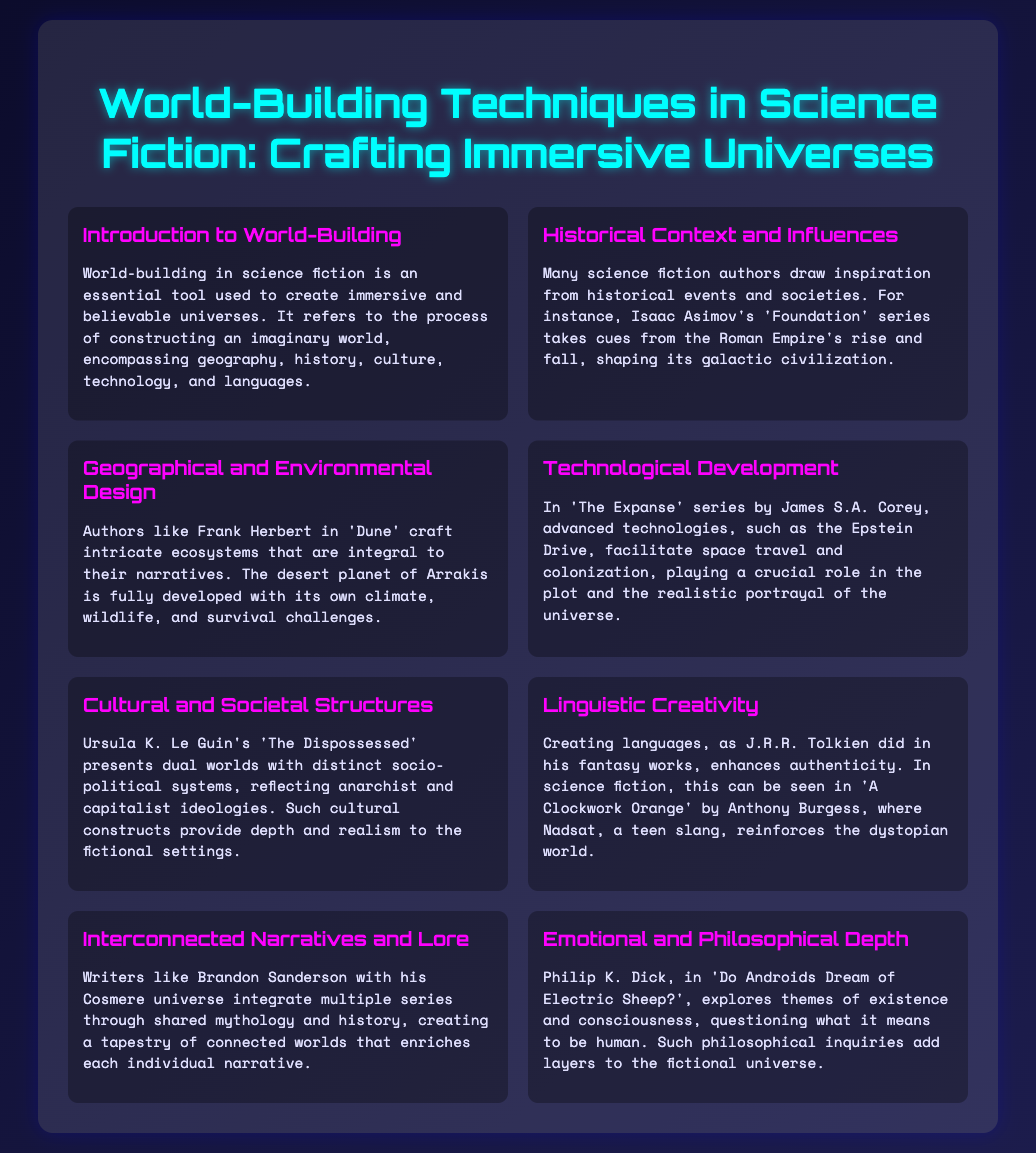What is the title of the presentation? The title of the presentation is provided in the header of the slide.
Answer: World-Building Techniques in Science Fiction: Crafting Immersive Universes Who wrote 'Foundation'? The author of 'Foundation' is mentioned in the context of historical influences on science fiction.
Answer: Isaac Asimov Which planet is integral to 'Dune'? This planet is specified as having a fully developed ecosystem in the section about geographical design.
Answer: Arrakis What technology facilitates space travel in 'The Expanse'? The specific technology is mentioned as crucial for realistic portrayals in the technological development section.
Answer: Epstein Drive What dual worlds are presented in 'The Dispossessed'? These worlds reflect different ideologies as stated in the cultural and societal structures section.
Answer: Anarchist and capitalist Which author explores themes of existence in their work? The author's name is highlighted in the emotional and philosophical depth section.
Answer: Philip K. Dick What linguistic creativity is showcased in 'A Clockwork Orange'? This refers to the unique language created in this work as highlighted in the linguistic creativity section.
Answer: Nadsat How does Brandon Sanderson connect his narratives? This is mentioned in relation to creating interconnected worlds in the respective section.
Answer: Shared mythology and history 